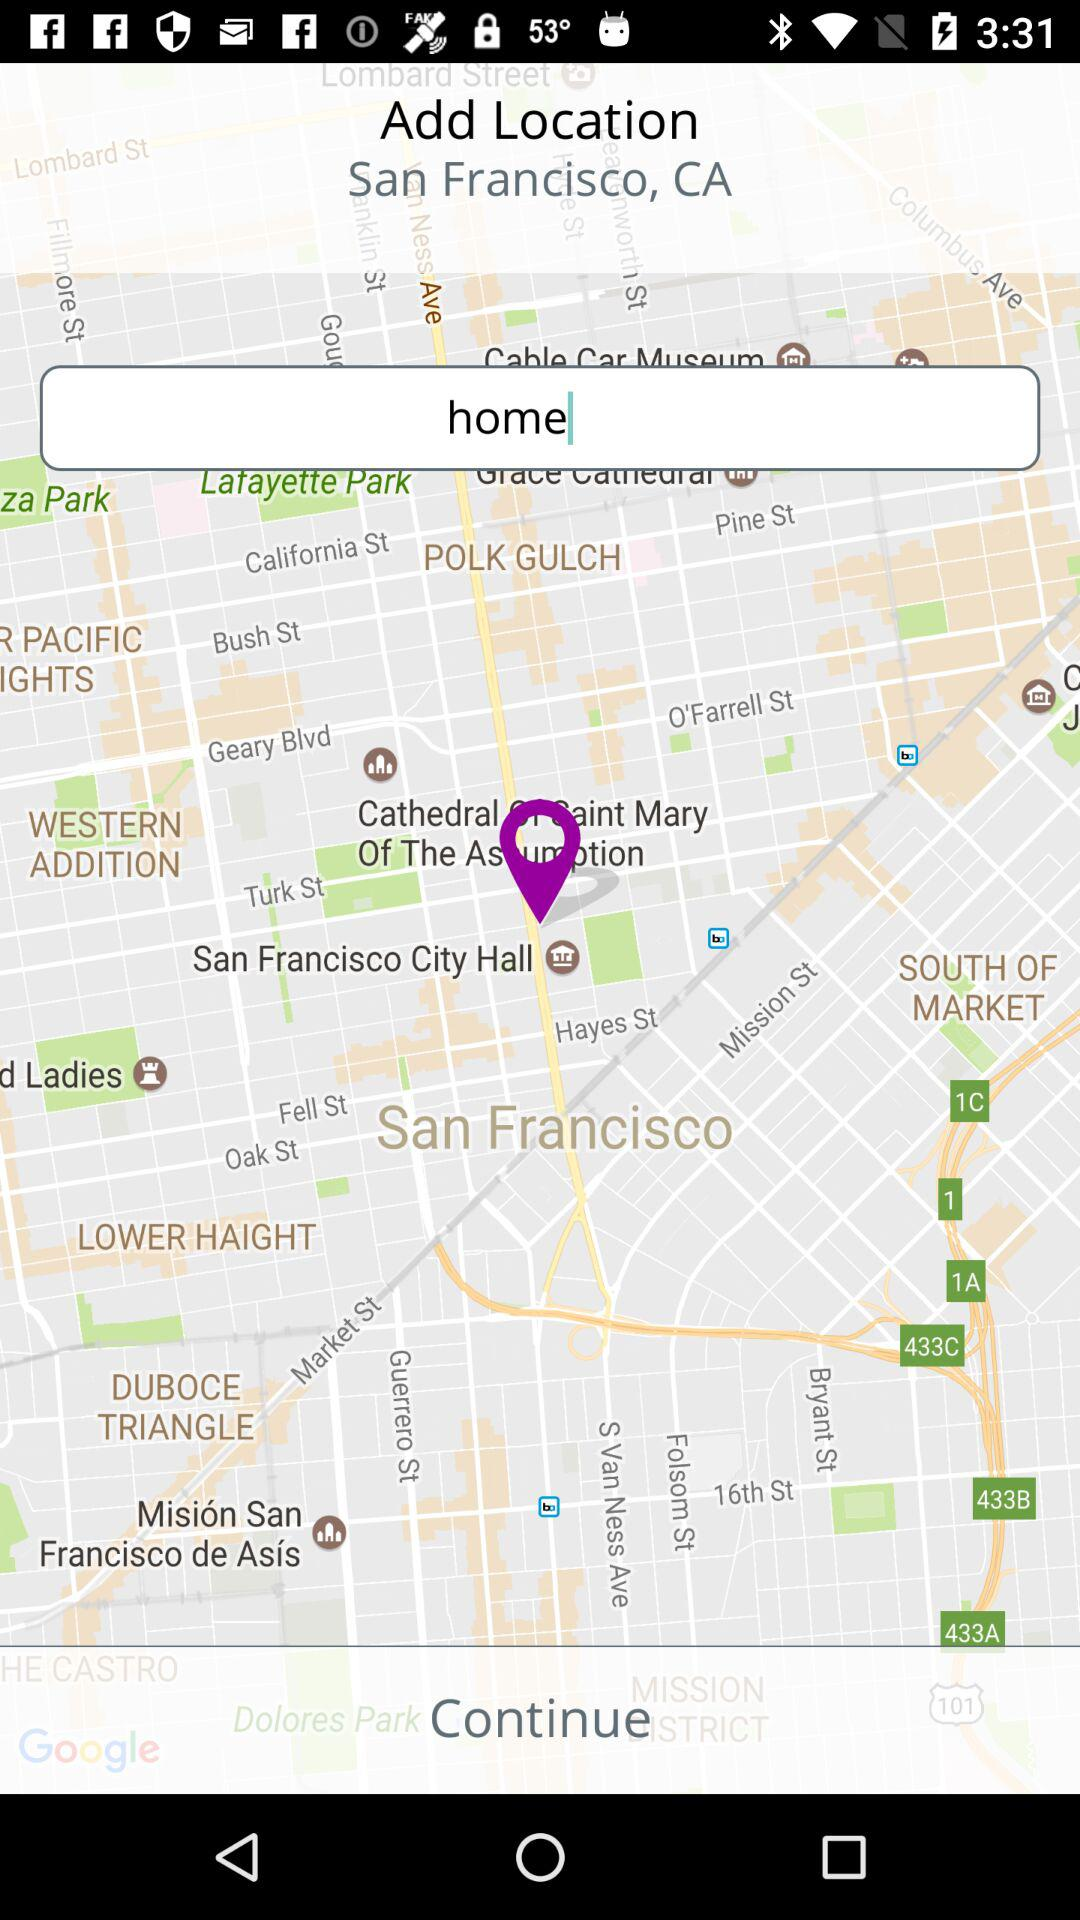What is the location? The location is San Francisco, CA. 